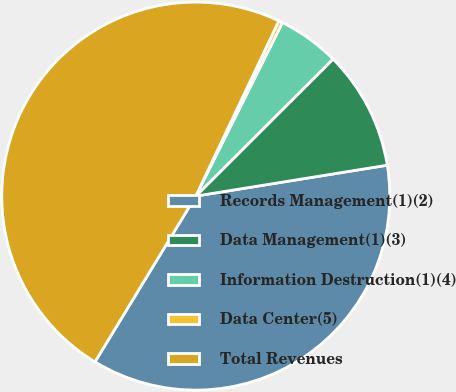<chart> <loc_0><loc_0><loc_500><loc_500><pie_chart><fcel>Records Management(1)(2)<fcel>Data Management(1)(3)<fcel>Information Destruction(1)(4)<fcel>Data Center(5)<fcel>Total Revenues<nl><fcel>36.24%<fcel>9.94%<fcel>5.14%<fcel>0.33%<fcel>48.35%<nl></chart> 